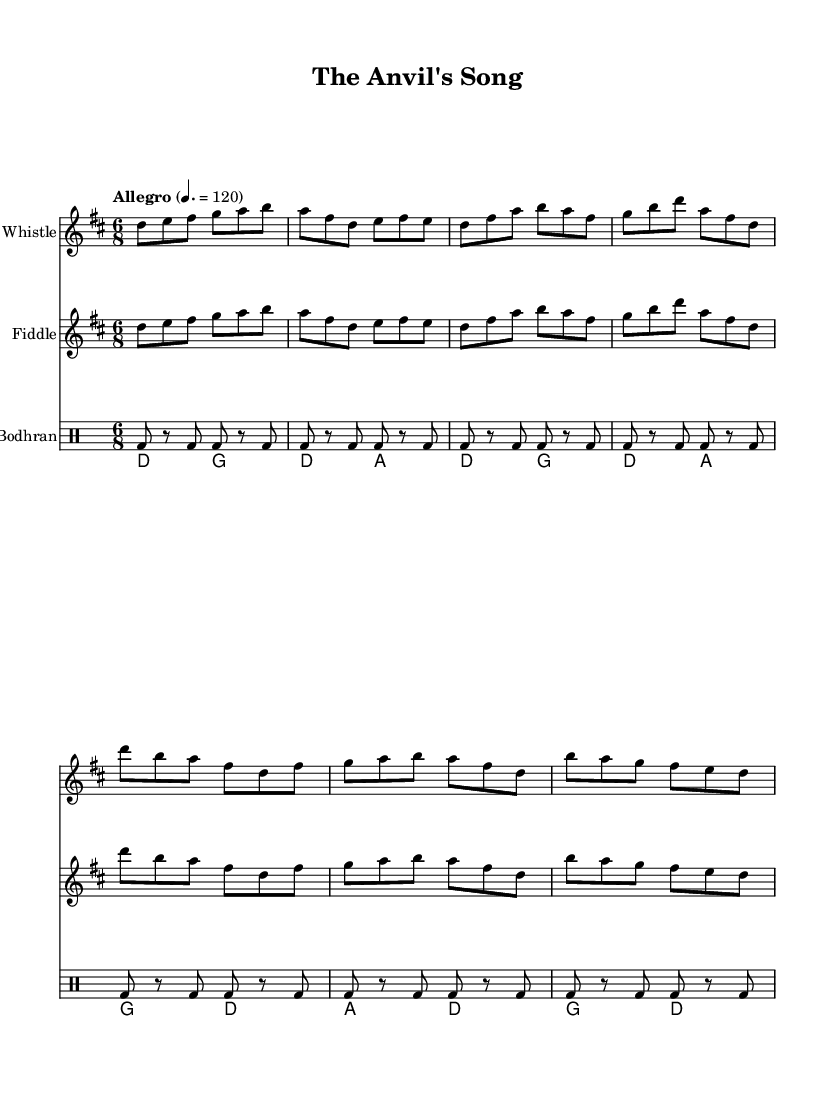What is the key signature of this music? The key signature is D major, which has two sharps (F# and C#). You can find this at the beginning of the staff lines.
Answer: D major What is the time signature of this music? The time signature is 6/8, indicated at the beginning of the score. This means there are six eighth notes per measure.
Answer: 6/8 What is the tempo marking of this piece? The tempo marking indicates "Allegro" with a speed of 120 beats per minute. This is found in the tempo section of the score.
Answer: 120 How many measures are in the chorus section? The chorus section consists of three measures as indicated by the repeated musical phrases Syllogistically analyzing the text notation will show three distinct groups.
Answer: 3 Which instrument plays the melody throughout the piece? The Tin Whistle plays the melody, as indicated by its presence with the same musical line repeated in the Fiddle staff.
Answer: Tin Whistle What is the rhythmic pattern used in the bodhran part? The bodhran has a repeating rhythm pattern consisting of a bass stroke on the first beat followed by rests and more strokes. This pattern is noted in the drummode section.
Answer: Bass, rest, bass, bass, rest, bass Which two chords are used in the guitar part? The guitar part features alternating use of D major and A major chords, both noted in the chord mode section of the score.
Answer: D major and A major 